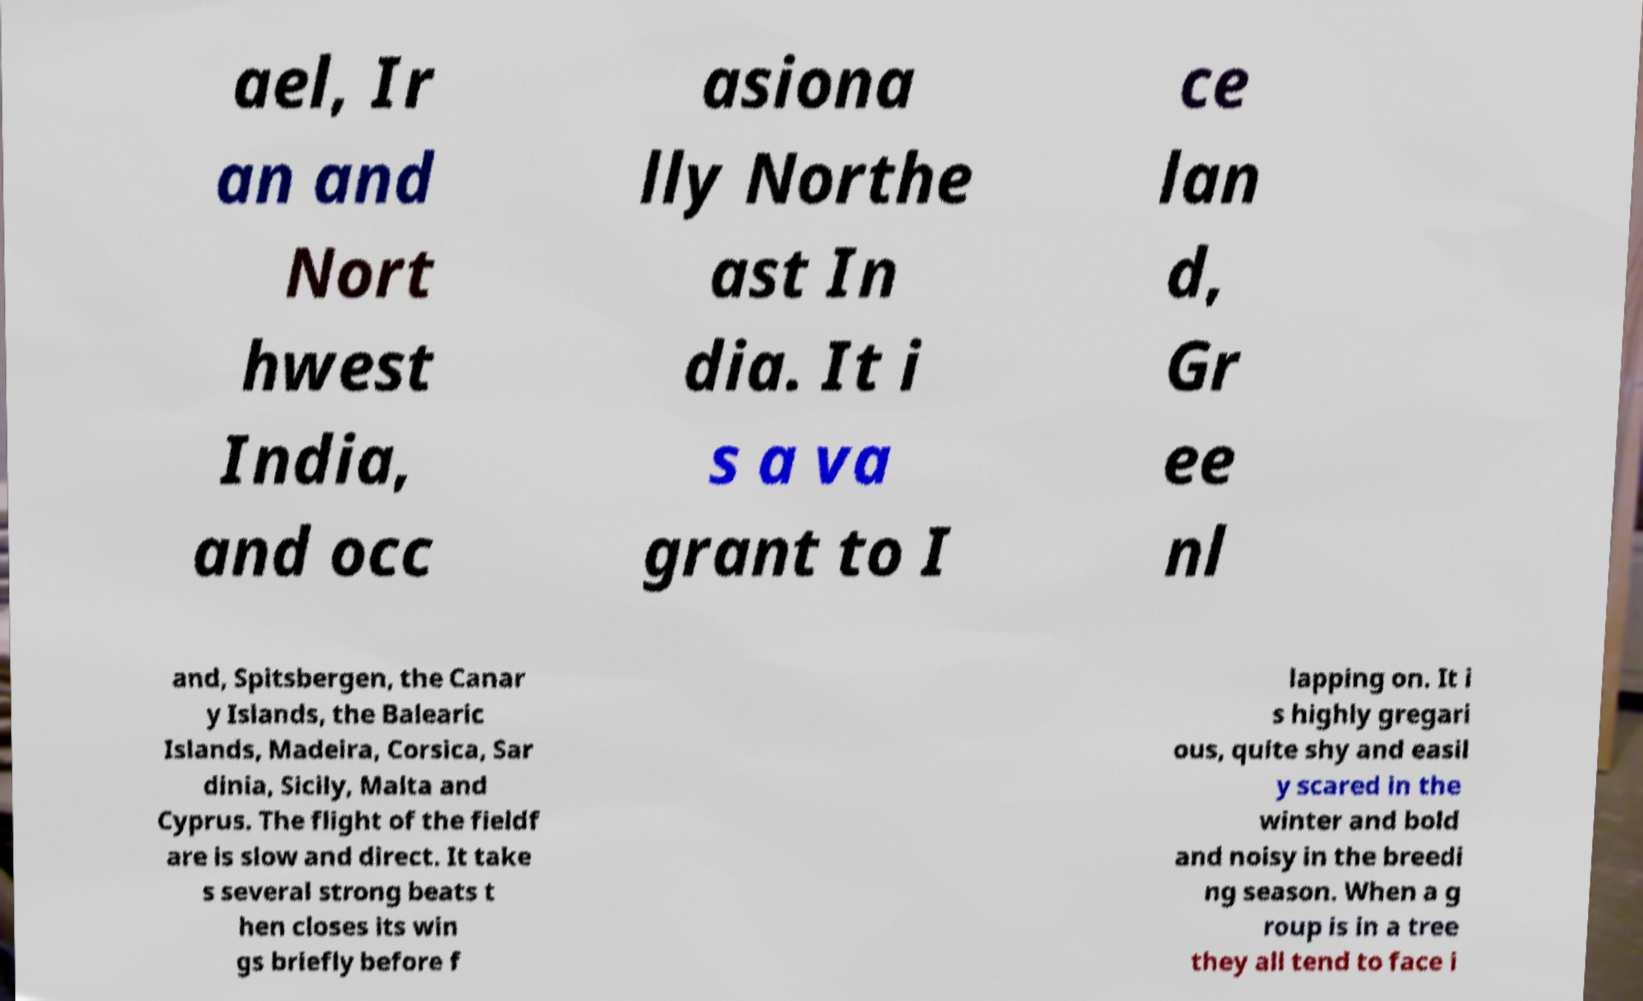Can you accurately transcribe the text from the provided image for me? ael, Ir an and Nort hwest India, and occ asiona lly Northe ast In dia. It i s a va grant to I ce lan d, Gr ee nl and, Spitsbergen, the Canar y Islands, the Balearic Islands, Madeira, Corsica, Sar dinia, Sicily, Malta and Cyprus. The flight of the fieldf are is slow and direct. It take s several strong beats t hen closes its win gs briefly before f lapping on. It i s highly gregari ous, quite shy and easil y scared in the winter and bold and noisy in the breedi ng season. When a g roup is in a tree they all tend to face i 